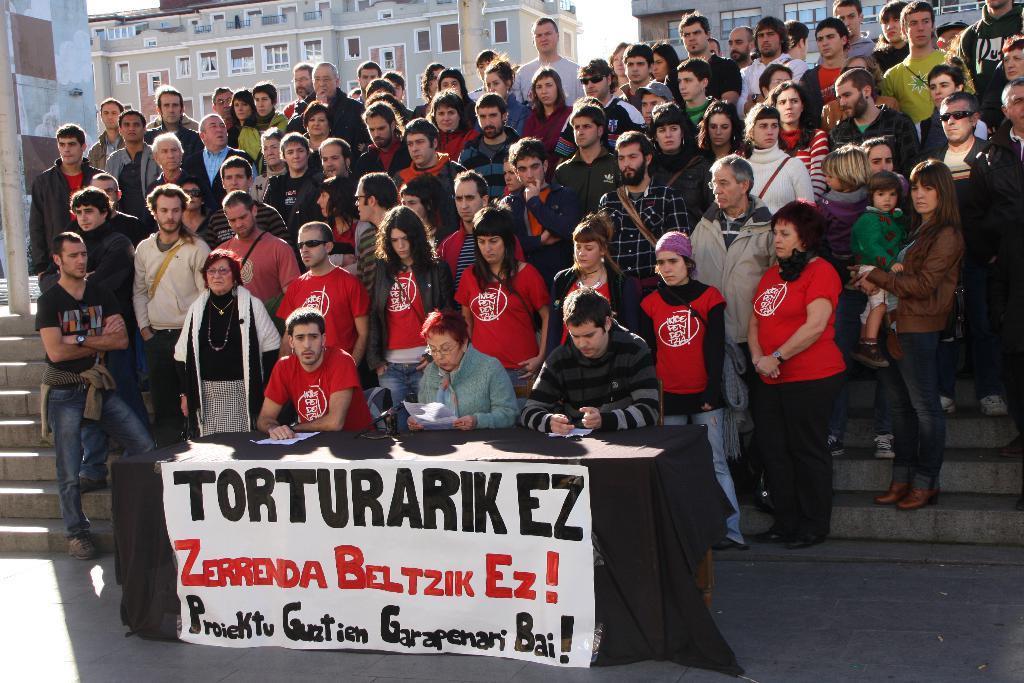In one or two sentences, can you explain what this image depicts? In this image, I can see a group of people standing. This is a table covered with a cloth. I can see three people sitting. This looks like a banner. In the background, I can see the buildings with the windows. These are the stairs. 